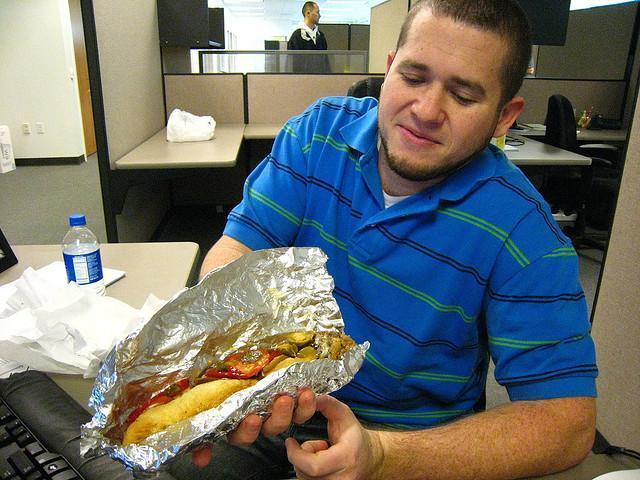How many sandwiches can be seen?
Give a very brief answer. 1. How many people are in the photo?
Give a very brief answer. 2. How many horses are there?
Give a very brief answer. 0. 